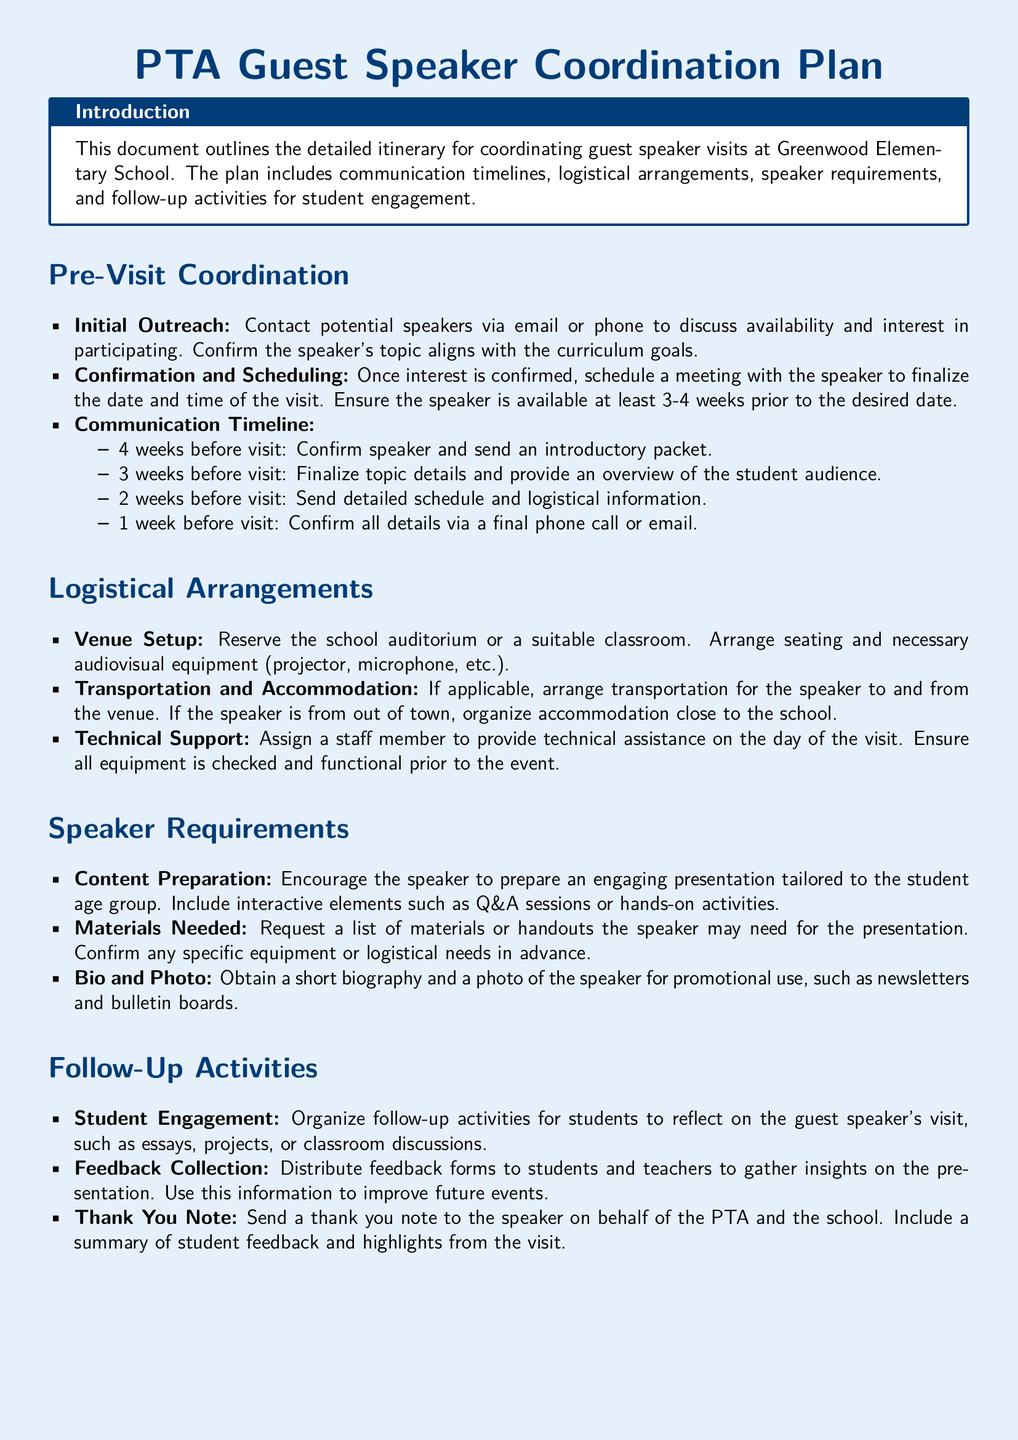What is the title of the document? The title of the document is stated at the top of the itinerary.
Answer: PTA Guest Speaker Coordination Plan How many weeks before the visit is the speaker confirmation sent? The document specifies that confirmation is sent 4 weeks before the visit.
Answer: 4 weeks What is the main venue reserved for guest speaker visits? The document mentions specific locations that are suitable for speaker visits.
Answer: School auditorium What is one requirement for the speaker's presentation? The document emphasizes preparing an engaging presentation tailored to the student age group.
Answer: Engaging presentation What should be collected after the speaker's visit? The itinerary outlines a process for gathering insights about the event from participants.
Answer: Feedback forms How many days prior to the event is technical support arranged? It specifies that a staff member is assigned for technical support on the day of the visit.
Answer: Day of the visit What type of activities should follow the guest speaker's visit? The document suggests activities for student reflection on the guest speaker's impact.
Answer: Follow-up activities What kind of note is suggested to be sent to the speaker? The document indicates sending correspondence to express gratitude and share student feedback.
Answer: Thank you note How many weeks in advance should the final details be confirmed? It is stated that all details should be confirmed 1 week prior to the visit.
Answer: 1 week 